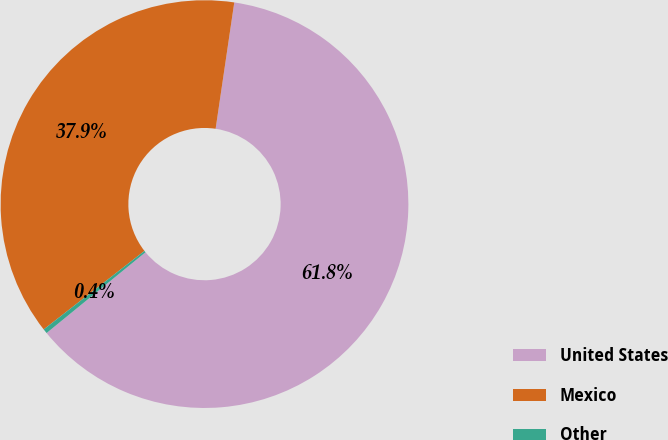Convert chart. <chart><loc_0><loc_0><loc_500><loc_500><pie_chart><fcel>United States<fcel>Mexico<fcel>Other<nl><fcel>61.77%<fcel>37.87%<fcel>0.36%<nl></chart> 